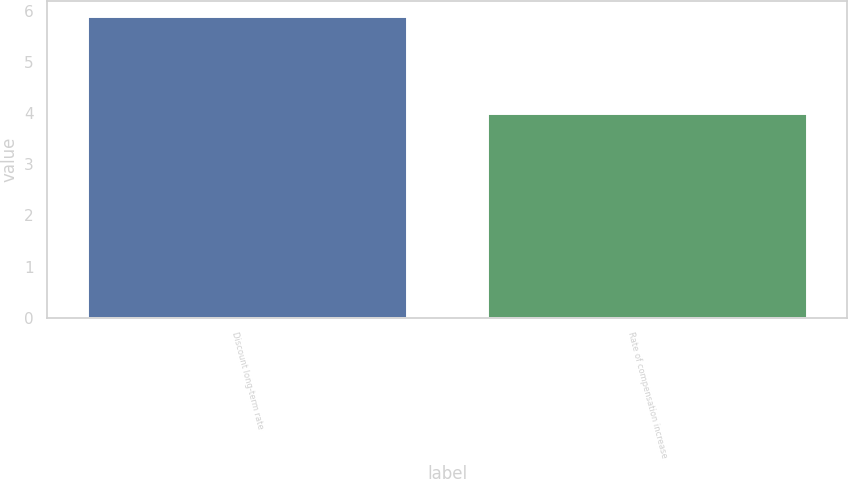Convert chart to OTSL. <chart><loc_0><loc_0><loc_500><loc_500><bar_chart><fcel>Discount long-term rate<fcel>Rate of compensation increase<nl><fcel>5.9<fcel>4<nl></chart> 